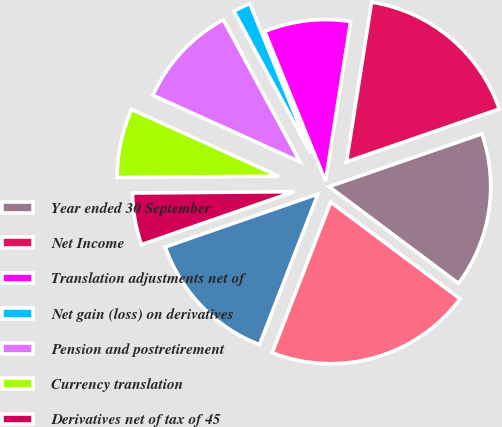<chart> <loc_0><loc_0><loc_500><loc_500><pie_chart><fcel>Year ended 30 September<fcel>Net Income<fcel>Translation adjustments net of<fcel>Net gain (loss) on derivatives<fcel>Pension and postretirement<fcel>Currency translation<fcel>Derivatives net of tax of 45<fcel>Total Other Comprehensive<fcel>Comprehensive Income<nl><fcel>15.51%<fcel>17.23%<fcel>8.62%<fcel>1.74%<fcel>10.35%<fcel>6.9%<fcel>5.18%<fcel>13.79%<fcel>20.67%<nl></chart> 